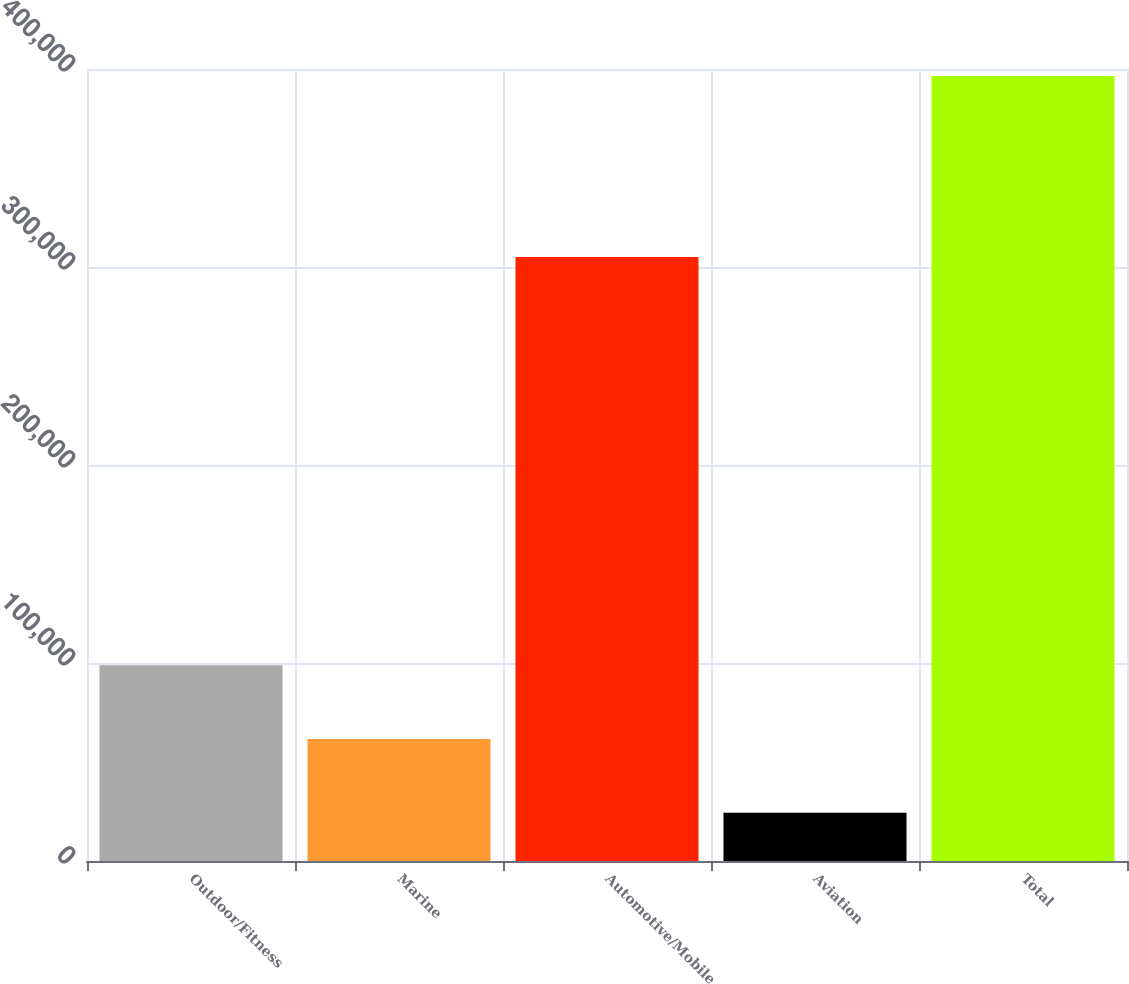Convert chart to OTSL. <chart><loc_0><loc_0><loc_500><loc_500><bar_chart><fcel>Outdoor/Fitness<fcel>Marine<fcel>Automotive/Mobile<fcel>Aviation<fcel>Total<nl><fcel>98819.6<fcel>61609.8<fcel>305065<fcel>24400<fcel>396498<nl></chart> 